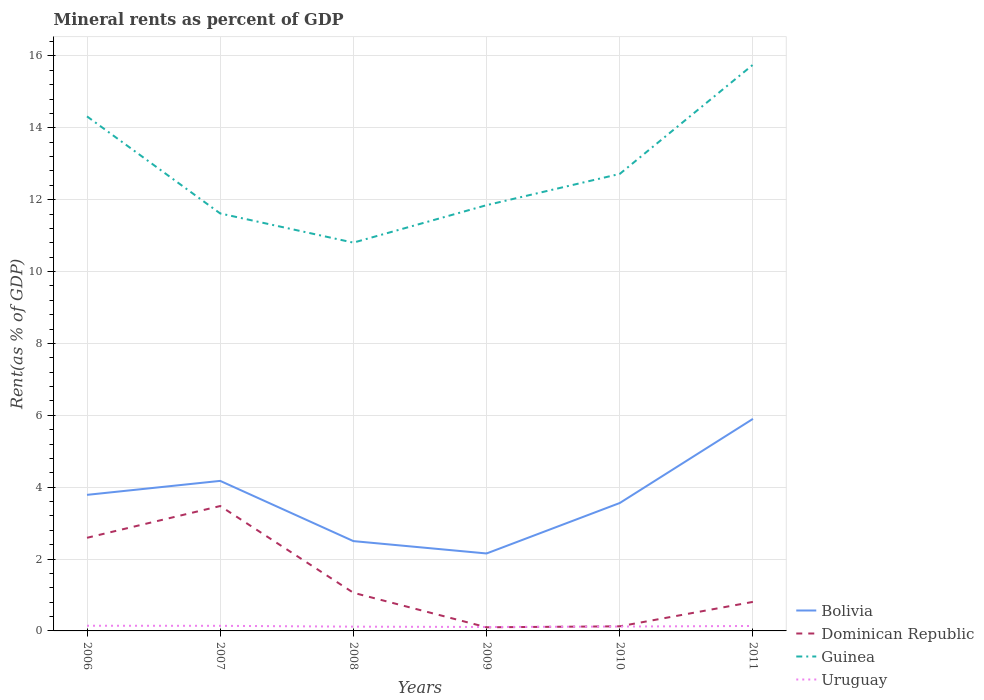Is the number of lines equal to the number of legend labels?
Offer a terse response. Yes. Across all years, what is the maximum mineral rent in Dominican Republic?
Provide a short and direct response. 0.1. What is the total mineral rent in Uruguay in the graph?
Offer a very short reply. -0.03. What is the difference between the highest and the second highest mineral rent in Uruguay?
Ensure brevity in your answer.  0.03. Is the mineral rent in Guinea strictly greater than the mineral rent in Dominican Republic over the years?
Make the answer very short. No. How many lines are there?
Make the answer very short. 4. Where does the legend appear in the graph?
Your response must be concise. Bottom right. How many legend labels are there?
Your answer should be very brief. 4. What is the title of the graph?
Your answer should be compact. Mineral rents as percent of GDP. Does "Rwanda" appear as one of the legend labels in the graph?
Your answer should be compact. No. What is the label or title of the Y-axis?
Ensure brevity in your answer.  Rent(as % of GDP). What is the Rent(as % of GDP) of Bolivia in 2006?
Make the answer very short. 3.79. What is the Rent(as % of GDP) in Dominican Republic in 2006?
Give a very brief answer. 2.59. What is the Rent(as % of GDP) in Guinea in 2006?
Your answer should be very brief. 14.32. What is the Rent(as % of GDP) in Uruguay in 2006?
Offer a terse response. 0.14. What is the Rent(as % of GDP) in Bolivia in 2007?
Your response must be concise. 4.17. What is the Rent(as % of GDP) in Dominican Republic in 2007?
Offer a terse response. 3.47. What is the Rent(as % of GDP) of Guinea in 2007?
Your answer should be very brief. 11.62. What is the Rent(as % of GDP) in Uruguay in 2007?
Your response must be concise. 0.14. What is the Rent(as % of GDP) of Bolivia in 2008?
Keep it short and to the point. 2.5. What is the Rent(as % of GDP) of Dominican Republic in 2008?
Your response must be concise. 1.06. What is the Rent(as % of GDP) of Guinea in 2008?
Keep it short and to the point. 10.8. What is the Rent(as % of GDP) in Uruguay in 2008?
Offer a very short reply. 0.12. What is the Rent(as % of GDP) in Bolivia in 2009?
Offer a terse response. 2.16. What is the Rent(as % of GDP) of Dominican Republic in 2009?
Offer a terse response. 0.1. What is the Rent(as % of GDP) of Guinea in 2009?
Give a very brief answer. 11.85. What is the Rent(as % of GDP) of Uruguay in 2009?
Give a very brief answer. 0.11. What is the Rent(as % of GDP) of Bolivia in 2010?
Keep it short and to the point. 3.56. What is the Rent(as % of GDP) in Dominican Republic in 2010?
Offer a terse response. 0.13. What is the Rent(as % of GDP) in Guinea in 2010?
Ensure brevity in your answer.  12.72. What is the Rent(as % of GDP) of Uruguay in 2010?
Ensure brevity in your answer.  0.12. What is the Rent(as % of GDP) in Bolivia in 2011?
Give a very brief answer. 5.9. What is the Rent(as % of GDP) of Dominican Republic in 2011?
Offer a terse response. 0.81. What is the Rent(as % of GDP) in Guinea in 2011?
Ensure brevity in your answer.  15.76. What is the Rent(as % of GDP) of Uruguay in 2011?
Give a very brief answer. 0.14. Across all years, what is the maximum Rent(as % of GDP) in Bolivia?
Give a very brief answer. 5.9. Across all years, what is the maximum Rent(as % of GDP) in Dominican Republic?
Make the answer very short. 3.47. Across all years, what is the maximum Rent(as % of GDP) in Guinea?
Keep it short and to the point. 15.76. Across all years, what is the maximum Rent(as % of GDP) of Uruguay?
Your response must be concise. 0.14. Across all years, what is the minimum Rent(as % of GDP) of Bolivia?
Provide a succinct answer. 2.16. Across all years, what is the minimum Rent(as % of GDP) in Dominican Republic?
Provide a short and direct response. 0.1. Across all years, what is the minimum Rent(as % of GDP) of Guinea?
Ensure brevity in your answer.  10.8. Across all years, what is the minimum Rent(as % of GDP) in Uruguay?
Offer a very short reply. 0.11. What is the total Rent(as % of GDP) in Bolivia in the graph?
Ensure brevity in your answer.  22.08. What is the total Rent(as % of GDP) of Dominican Republic in the graph?
Keep it short and to the point. 8.17. What is the total Rent(as % of GDP) in Guinea in the graph?
Provide a succinct answer. 77.06. What is the total Rent(as % of GDP) of Uruguay in the graph?
Offer a very short reply. 0.77. What is the difference between the Rent(as % of GDP) in Bolivia in 2006 and that in 2007?
Offer a terse response. -0.39. What is the difference between the Rent(as % of GDP) of Dominican Republic in 2006 and that in 2007?
Ensure brevity in your answer.  -0.88. What is the difference between the Rent(as % of GDP) of Guinea in 2006 and that in 2007?
Ensure brevity in your answer.  2.7. What is the difference between the Rent(as % of GDP) in Uruguay in 2006 and that in 2007?
Offer a very short reply. 0. What is the difference between the Rent(as % of GDP) of Bolivia in 2006 and that in 2008?
Provide a short and direct response. 1.29. What is the difference between the Rent(as % of GDP) in Dominican Republic in 2006 and that in 2008?
Provide a short and direct response. 1.53. What is the difference between the Rent(as % of GDP) of Guinea in 2006 and that in 2008?
Provide a short and direct response. 3.51. What is the difference between the Rent(as % of GDP) of Uruguay in 2006 and that in 2008?
Offer a very short reply. 0.03. What is the difference between the Rent(as % of GDP) in Bolivia in 2006 and that in 2009?
Offer a terse response. 1.63. What is the difference between the Rent(as % of GDP) of Dominican Republic in 2006 and that in 2009?
Your answer should be compact. 2.49. What is the difference between the Rent(as % of GDP) in Guinea in 2006 and that in 2009?
Your answer should be compact. 2.47. What is the difference between the Rent(as % of GDP) in Uruguay in 2006 and that in 2009?
Offer a terse response. 0.03. What is the difference between the Rent(as % of GDP) in Bolivia in 2006 and that in 2010?
Offer a very short reply. 0.23. What is the difference between the Rent(as % of GDP) of Dominican Republic in 2006 and that in 2010?
Offer a very short reply. 2.46. What is the difference between the Rent(as % of GDP) in Guinea in 2006 and that in 2010?
Offer a terse response. 1.6. What is the difference between the Rent(as % of GDP) in Uruguay in 2006 and that in 2010?
Make the answer very short. 0.02. What is the difference between the Rent(as % of GDP) of Bolivia in 2006 and that in 2011?
Your answer should be compact. -2.11. What is the difference between the Rent(as % of GDP) of Dominican Republic in 2006 and that in 2011?
Make the answer very short. 1.78. What is the difference between the Rent(as % of GDP) of Guinea in 2006 and that in 2011?
Keep it short and to the point. -1.44. What is the difference between the Rent(as % of GDP) in Uruguay in 2006 and that in 2011?
Your answer should be compact. 0.01. What is the difference between the Rent(as % of GDP) of Bolivia in 2007 and that in 2008?
Offer a terse response. 1.68. What is the difference between the Rent(as % of GDP) of Dominican Republic in 2007 and that in 2008?
Give a very brief answer. 2.41. What is the difference between the Rent(as % of GDP) of Guinea in 2007 and that in 2008?
Ensure brevity in your answer.  0.81. What is the difference between the Rent(as % of GDP) of Uruguay in 2007 and that in 2008?
Offer a terse response. 0.02. What is the difference between the Rent(as % of GDP) of Bolivia in 2007 and that in 2009?
Your response must be concise. 2.02. What is the difference between the Rent(as % of GDP) in Dominican Republic in 2007 and that in 2009?
Your answer should be very brief. 3.37. What is the difference between the Rent(as % of GDP) of Guinea in 2007 and that in 2009?
Your answer should be very brief. -0.23. What is the difference between the Rent(as % of GDP) of Uruguay in 2007 and that in 2009?
Your answer should be compact. 0.03. What is the difference between the Rent(as % of GDP) in Bolivia in 2007 and that in 2010?
Your answer should be very brief. 0.62. What is the difference between the Rent(as % of GDP) in Dominican Republic in 2007 and that in 2010?
Make the answer very short. 3.35. What is the difference between the Rent(as % of GDP) of Guinea in 2007 and that in 2010?
Your response must be concise. -1.1. What is the difference between the Rent(as % of GDP) of Uruguay in 2007 and that in 2010?
Provide a succinct answer. 0.02. What is the difference between the Rent(as % of GDP) in Bolivia in 2007 and that in 2011?
Offer a terse response. -1.73. What is the difference between the Rent(as % of GDP) of Dominican Republic in 2007 and that in 2011?
Make the answer very short. 2.67. What is the difference between the Rent(as % of GDP) of Guinea in 2007 and that in 2011?
Provide a short and direct response. -4.14. What is the difference between the Rent(as % of GDP) in Uruguay in 2007 and that in 2011?
Provide a succinct answer. 0. What is the difference between the Rent(as % of GDP) in Bolivia in 2008 and that in 2009?
Offer a very short reply. 0.34. What is the difference between the Rent(as % of GDP) in Dominican Republic in 2008 and that in 2009?
Your answer should be compact. 0.96. What is the difference between the Rent(as % of GDP) of Guinea in 2008 and that in 2009?
Provide a succinct answer. -1.04. What is the difference between the Rent(as % of GDP) of Uruguay in 2008 and that in 2009?
Ensure brevity in your answer.  0.01. What is the difference between the Rent(as % of GDP) in Bolivia in 2008 and that in 2010?
Your answer should be very brief. -1.06. What is the difference between the Rent(as % of GDP) in Dominican Republic in 2008 and that in 2010?
Offer a very short reply. 0.93. What is the difference between the Rent(as % of GDP) in Guinea in 2008 and that in 2010?
Offer a terse response. -1.91. What is the difference between the Rent(as % of GDP) in Uruguay in 2008 and that in 2010?
Your answer should be very brief. -0. What is the difference between the Rent(as % of GDP) in Bolivia in 2008 and that in 2011?
Give a very brief answer. -3.4. What is the difference between the Rent(as % of GDP) of Dominican Republic in 2008 and that in 2011?
Ensure brevity in your answer.  0.25. What is the difference between the Rent(as % of GDP) of Guinea in 2008 and that in 2011?
Provide a short and direct response. -4.95. What is the difference between the Rent(as % of GDP) of Uruguay in 2008 and that in 2011?
Make the answer very short. -0.02. What is the difference between the Rent(as % of GDP) in Bolivia in 2009 and that in 2010?
Make the answer very short. -1.4. What is the difference between the Rent(as % of GDP) of Dominican Republic in 2009 and that in 2010?
Offer a terse response. -0.03. What is the difference between the Rent(as % of GDP) of Guinea in 2009 and that in 2010?
Offer a very short reply. -0.87. What is the difference between the Rent(as % of GDP) in Uruguay in 2009 and that in 2010?
Provide a short and direct response. -0.01. What is the difference between the Rent(as % of GDP) in Bolivia in 2009 and that in 2011?
Your answer should be compact. -3.75. What is the difference between the Rent(as % of GDP) in Dominican Republic in 2009 and that in 2011?
Your answer should be compact. -0.71. What is the difference between the Rent(as % of GDP) of Guinea in 2009 and that in 2011?
Offer a terse response. -3.91. What is the difference between the Rent(as % of GDP) of Uruguay in 2009 and that in 2011?
Make the answer very short. -0.03. What is the difference between the Rent(as % of GDP) of Bolivia in 2010 and that in 2011?
Keep it short and to the point. -2.34. What is the difference between the Rent(as % of GDP) of Dominican Republic in 2010 and that in 2011?
Offer a very short reply. -0.68. What is the difference between the Rent(as % of GDP) in Guinea in 2010 and that in 2011?
Ensure brevity in your answer.  -3.04. What is the difference between the Rent(as % of GDP) of Uruguay in 2010 and that in 2011?
Give a very brief answer. -0.02. What is the difference between the Rent(as % of GDP) of Bolivia in 2006 and the Rent(as % of GDP) of Dominican Republic in 2007?
Your response must be concise. 0.31. What is the difference between the Rent(as % of GDP) in Bolivia in 2006 and the Rent(as % of GDP) in Guinea in 2007?
Offer a terse response. -7.83. What is the difference between the Rent(as % of GDP) of Bolivia in 2006 and the Rent(as % of GDP) of Uruguay in 2007?
Give a very brief answer. 3.64. What is the difference between the Rent(as % of GDP) of Dominican Republic in 2006 and the Rent(as % of GDP) of Guinea in 2007?
Keep it short and to the point. -9.02. What is the difference between the Rent(as % of GDP) of Dominican Republic in 2006 and the Rent(as % of GDP) of Uruguay in 2007?
Your answer should be compact. 2.45. What is the difference between the Rent(as % of GDP) in Guinea in 2006 and the Rent(as % of GDP) in Uruguay in 2007?
Make the answer very short. 14.18. What is the difference between the Rent(as % of GDP) in Bolivia in 2006 and the Rent(as % of GDP) in Dominican Republic in 2008?
Offer a very short reply. 2.72. What is the difference between the Rent(as % of GDP) in Bolivia in 2006 and the Rent(as % of GDP) in Guinea in 2008?
Keep it short and to the point. -7.02. What is the difference between the Rent(as % of GDP) in Bolivia in 2006 and the Rent(as % of GDP) in Uruguay in 2008?
Offer a terse response. 3.67. What is the difference between the Rent(as % of GDP) in Dominican Republic in 2006 and the Rent(as % of GDP) in Guinea in 2008?
Make the answer very short. -8.21. What is the difference between the Rent(as % of GDP) of Dominican Republic in 2006 and the Rent(as % of GDP) of Uruguay in 2008?
Provide a short and direct response. 2.47. What is the difference between the Rent(as % of GDP) of Guinea in 2006 and the Rent(as % of GDP) of Uruguay in 2008?
Ensure brevity in your answer.  14.2. What is the difference between the Rent(as % of GDP) in Bolivia in 2006 and the Rent(as % of GDP) in Dominican Republic in 2009?
Provide a succinct answer. 3.68. What is the difference between the Rent(as % of GDP) of Bolivia in 2006 and the Rent(as % of GDP) of Guinea in 2009?
Your response must be concise. -8.06. What is the difference between the Rent(as % of GDP) in Bolivia in 2006 and the Rent(as % of GDP) in Uruguay in 2009?
Offer a very short reply. 3.68. What is the difference between the Rent(as % of GDP) in Dominican Republic in 2006 and the Rent(as % of GDP) in Guinea in 2009?
Your answer should be compact. -9.26. What is the difference between the Rent(as % of GDP) of Dominican Republic in 2006 and the Rent(as % of GDP) of Uruguay in 2009?
Ensure brevity in your answer.  2.48. What is the difference between the Rent(as % of GDP) of Guinea in 2006 and the Rent(as % of GDP) of Uruguay in 2009?
Your answer should be compact. 14.21. What is the difference between the Rent(as % of GDP) of Bolivia in 2006 and the Rent(as % of GDP) of Dominican Republic in 2010?
Provide a short and direct response. 3.66. What is the difference between the Rent(as % of GDP) in Bolivia in 2006 and the Rent(as % of GDP) in Guinea in 2010?
Your response must be concise. -8.93. What is the difference between the Rent(as % of GDP) in Bolivia in 2006 and the Rent(as % of GDP) in Uruguay in 2010?
Provide a short and direct response. 3.66. What is the difference between the Rent(as % of GDP) of Dominican Republic in 2006 and the Rent(as % of GDP) of Guinea in 2010?
Your answer should be very brief. -10.13. What is the difference between the Rent(as % of GDP) of Dominican Republic in 2006 and the Rent(as % of GDP) of Uruguay in 2010?
Offer a terse response. 2.47. What is the difference between the Rent(as % of GDP) in Guinea in 2006 and the Rent(as % of GDP) in Uruguay in 2010?
Offer a terse response. 14.2. What is the difference between the Rent(as % of GDP) in Bolivia in 2006 and the Rent(as % of GDP) in Dominican Republic in 2011?
Provide a succinct answer. 2.98. What is the difference between the Rent(as % of GDP) of Bolivia in 2006 and the Rent(as % of GDP) of Guinea in 2011?
Your answer should be very brief. -11.97. What is the difference between the Rent(as % of GDP) in Bolivia in 2006 and the Rent(as % of GDP) in Uruguay in 2011?
Provide a succinct answer. 3.65. What is the difference between the Rent(as % of GDP) in Dominican Republic in 2006 and the Rent(as % of GDP) in Guinea in 2011?
Provide a short and direct response. -13.16. What is the difference between the Rent(as % of GDP) in Dominican Republic in 2006 and the Rent(as % of GDP) in Uruguay in 2011?
Provide a succinct answer. 2.45. What is the difference between the Rent(as % of GDP) of Guinea in 2006 and the Rent(as % of GDP) of Uruguay in 2011?
Your answer should be compact. 14.18. What is the difference between the Rent(as % of GDP) in Bolivia in 2007 and the Rent(as % of GDP) in Dominican Republic in 2008?
Your response must be concise. 3.11. What is the difference between the Rent(as % of GDP) of Bolivia in 2007 and the Rent(as % of GDP) of Guinea in 2008?
Your answer should be compact. -6.63. What is the difference between the Rent(as % of GDP) in Bolivia in 2007 and the Rent(as % of GDP) in Uruguay in 2008?
Your answer should be very brief. 4.06. What is the difference between the Rent(as % of GDP) in Dominican Republic in 2007 and the Rent(as % of GDP) in Guinea in 2008?
Provide a succinct answer. -7.33. What is the difference between the Rent(as % of GDP) of Dominican Republic in 2007 and the Rent(as % of GDP) of Uruguay in 2008?
Provide a succinct answer. 3.36. What is the difference between the Rent(as % of GDP) in Guinea in 2007 and the Rent(as % of GDP) in Uruguay in 2008?
Your response must be concise. 11.5. What is the difference between the Rent(as % of GDP) in Bolivia in 2007 and the Rent(as % of GDP) in Dominican Republic in 2009?
Your response must be concise. 4.07. What is the difference between the Rent(as % of GDP) of Bolivia in 2007 and the Rent(as % of GDP) of Guinea in 2009?
Your answer should be very brief. -7.67. What is the difference between the Rent(as % of GDP) in Bolivia in 2007 and the Rent(as % of GDP) in Uruguay in 2009?
Ensure brevity in your answer.  4.07. What is the difference between the Rent(as % of GDP) in Dominican Republic in 2007 and the Rent(as % of GDP) in Guinea in 2009?
Give a very brief answer. -8.37. What is the difference between the Rent(as % of GDP) in Dominican Republic in 2007 and the Rent(as % of GDP) in Uruguay in 2009?
Ensure brevity in your answer.  3.37. What is the difference between the Rent(as % of GDP) in Guinea in 2007 and the Rent(as % of GDP) in Uruguay in 2009?
Give a very brief answer. 11.51. What is the difference between the Rent(as % of GDP) of Bolivia in 2007 and the Rent(as % of GDP) of Dominican Republic in 2010?
Provide a short and direct response. 4.05. What is the difference between the Rent(as % of GDP) in Bolivia in 2007 and the Rent(as % of GDP) in Guinea in 2010?
Offer a terse response. -8.54. What is the difference between the Rent(as % of GDP) of Bolivia in 2007 and the Rent(as % of GDP) of Uruguay in 2010?
Your response must be concise. 4.05. What is the difference between the Rent(as % of GDP) of Dominican Republic in 2007 and the Rent(as % of GDP) of Guinea in 2010?
Offer a very short reply. -9.24. What is the difference between the Rent(as % of GDP) of Dominican Republic in 2007 and the Rent(as % of GDP) of Uruguay in 2010?
Your answer should be very brief. 3.35. What is the difference between the Rent(as % of GDP) of Guinea in 2007 and the Rent(as % of GDP) of Uruguay in 2010?
Give a very brief answer. 11.49. What is the difference between the Rent(as % of GDP) in Bolivia in 2007 and the Rent(as % of GDP) in Dominican Republic in 2011?
Keep it short and to the point. 3.37. What is the difference between the Rent(as % of GDP) in Bolivia in 2007 and the Rent(as % of GDP) in Guinea in 2011?
Offer a very short reply. -11.58. What is the difference between the Rent(as % of GDP) of Bolivia in 2007 and the Rent(as % of GDP) of Uruguay in 2011?
Offer a terse response. 4.04. What is the difference between the Rent(as % of GDP) in Dominican Republic in 2007 and the Rent(as % of GDP) in Guinea in 2011?
Provide a short and direct response. -12.28. What is the difference between the Rent(as % of GDP) of Dominican Republic in 2007 and the Rent(as % of GDP) of Uruguay in 2011?
Your answer should be compact. 3.34. What is the difference between the Rent(as % of GDP) of Guinea in 2007 and the Rent(as % of GDP) of Uruguay in 2011?
Offer a very short reply. 11.48. What is the difference between the Rent(as % of GDP) of Bolivia in 2008 and the Rent(as % of GDP) of Dominican Republic in 2009?
Provide a succinct answer. 2.4. What is the difference between the Rent(as % of GDP) in Bolivia in 2008 and the Rent(as % of GDP) in Guinea in 2009?
Make the answer very short. -9.35. What is the difference between the Rent(as % of GDP) in Bolivia in 2008 and the Rent(as % of GDP) in Uruguay in 2009?
Your response must be concise. 2.39. What is the difference between the Rent(as % of GDP) in Dominican Republic in 2008 and the Rent(as % of GDP) in Guinea in 2009?
Ensure brevity in your answer.  -10.79. What is the difference between the Rent(as % of GDP) of Dominican Republic in 2008 and the Rent(as % of GDP) of Uruguay in 2009?
Your response must be concise. 0.95. What is the difference between the Rent(as % of GDP) in Guinea in 2008 and the Rent(as % of GDP) in Uruguay in 2009?
Ensure brevity in your answer.  10.69. What is the difference between the Rent(as % of GDP) in Bolivia in 2008 and the Rent(as % of GDP) in Dominican Republic in 2010?
Your response must be concise. 2.37. What is the difference between the Rent(as % of GDP) of Bolivia in 2008 and the Rent(as % of GDP) of Guinea in 2010?
Provide a succinct answer. -10.22. What is the difference between the Rent(as % of GDP) of Bolivia in 2008 and the Rent(as % of GDP) of Uruguay in 2010?
Provide a short and direct response. 2.38. What is the difference between the Rent(as % of GDP) of Dominican Republic in 2008 and the Rent(as % of GDP) of Guinea in 2010?
Your answer should be very brief. -11.66. What is the difference between the Rent(as % of GDP) in Dominican Republic in 2008 and the Rent(as % of GDP) in Uruguay in 2010?
Ensure brevity in your answer.  0.94. What is the difference between the Rent(as % of GDP) of Guinea in 2008 and the Rent(as % of GDP) of Uruguay in 2010?
Provide a short and direct response. 10.68. What is the difference between the Rent(as % of GDP) in Bolivia in 2008 and the Rent(as % of GDP) in Dominican Republic in 2011?
Your answer should be very brief. 1.69. What is the difference between the Rent(as % of GDP) of Bolivia in 2008 and the Rent(as % of GDP) of Guinea in 2011?
Offer a very short reply. -13.26. What is the difference between the Rent(as % of GDP) in Bolivia in 2008 and the Rent(as % of GDP) in Uruguay in 2011?
Make the answer very short. 2.36. What is the difference between the Rent(as % of GDP) in Dominican Republic in 2008 and the Rent(as % of GDP) in Guinea in 2011?
Offer a terse response. -14.69. What is the difference between the Rent(as % of GDP) in Dominican Republic in 2008 and the Rent(as % of GDP) in Uruguay in 2011?
Your response must be concise. 0.92. What is the difference between the Rent(as % of GDP) in Guinea in 2008 and the Rent(as % of GDP) in Uruguay in 2011?
Offer a very short reply. 10.67. What is the difference between the Rent(as % of GDP) of Bolivia in 2009 and the Rent(as % of GDP) of Dominican Republic in 2010?
Your answer should be very brief. 2.03. What is the difference between the Rent(as % of GDP) of Bolivia in 2009 and the Rent(as % of GDP) of Guinea in 2010?
Your answer should be very brief. -10.56. What is the difference between the Rent(as % of GDP) of Bolivia in 2009 and the Rent(as % of GDP) of Uruguay in 2010?
Your answer should be very brief. 2.03. What is the difference between the Rent(as % of GDP) in Dominican Republic in 2009 and the Rent(as % of GDP) in Guinea in 2010?
Offer a very short reply. -12.62. What is the difference between the Rent(as % of GDP) in Dominican Republic in 2009 and the Rent(as % of GDP) in Uruguay in 2010?
Provide a short and direct response. -0.02. What is the difference between the Rent(as % of GDP) of Guinea in 2009 and the Rent(as % of GDP) of Uruguay in 2010?
Provide a short and direct response. 11.73. What is the difference between the Rent(as % of GDP) in Bolivia in 2009 and the Rent(as % of GDP) in Dominican Republic in 2011?
Your answer should be very brief. 1.35. What is the difference between the Rent(as % of GDP) in Bolivia in 2009 and the Rent(as % of GDP) in Guinea in 2011?
Keep it short and to the point. -13.6. What is the difference between the Rent(as % of GDP) of Bolivia in 2009 and the Rent(as % of GDP) of Uruguay in 2011?
Your answer should be compact. 2.02. What is the difference between the Rent(as % of GDP) in Dominican Republic in 2009 and the Rent(as % of GDP) in Guinea in 2011?
Ensure brevity in your answer.  -15.65. What is the difference between the Rent(as % of GDP) in Dominican Republic in 2009 and the Rent(as % of GDP) in Uruguay in 2011?
Give a very brief answer. -0.04. What is the difference between the Rent(as % of GDP) of Guinea in 2009 and the Rent(as % of GDP) of Uruguay in 2011?
Offer a very short reply. 11.71. What is the difference between the Rent(as % of GDP) of Bolivia in 2010 and the Rent(as % of GDP) of Dominican Republic in 2011?
Offer a very short reply. 2.75. What is the difference between the Rent(as % of GDP) of Bolivia in 2010 and the Rent(as % of GDP) of Guinea in 2011?
Make the answer very short. -12.2. What is the difference between the Rent(as % of GDP) of Bolivia in 2010 and the Rent(as % of GDP) of Uruguay in 2011?
Your answer should be very brief. 3.42. What is the difference between the Rent(as % of GDP) in Dominican Republic in 2010 and the Rent(as % of GDP) in Guinea in 2011?
Give a very brief answer. -15.63. What is the difference between the Rent(as % of GDP) in Dominican Republic in 2010 and the Rent(as % of GDP) in Uruguay in 2011?
Offer a very short reply. -0.01. What is the difference between the Rent(as % of GDP) in Guinea in 2010 and the Rent(as % of GDP) in Uruguay in 2011?
Your answer should be very brief. 12.58. What is the average Rent(as % of GDP) in Bolivia per year?
Offer a very short reply. 3.68. What is the average Rent(as % of GDP) of Dominican Republic per year?
Offer a terse response. 1.36. What is the average Rent(as % of GDP) in Guinea per year?
Offer a very short reply. 12.84. What is the average Rent(as % of GDP) in Uruguay per year?
Offer a terse response. 0.13. In the year 2006, what is the difference between the Rent(as % of GDP) in Bolivia and Rent(as % of GDP) in Dominican Republic?
Your answer should be compact. 1.19. In the year 2006, what is the difference between the Rent(as % of GDP) in Bolivia and Rent(as % of GDP) in Guinea?
Provide a succinct answer. -10.53. In the year 2006, what is the difference between the Rent(as % of GDP) of Bolivia and Rent(as % of GDP) of Uruguay?
Your response must be concise. 3.64. In the year 2006, what is the difference between the Rent(as % of GDP) in Dominican Republic and Rent(as % of GDP) in Guinea?
Keep it short and to the point. -11.73. In the year 2006, what is the difference between the Rent(as % of GDP) of Dominican Republic and Rent(as % of GDP) of Uruguay?
Provide a short and direct response. 2.45. In the year 2006, what is the difference between the Rent(as % of GDP) of Guinea and Rent(as % of GDP) of Uruguay?
Provide a short and direct response. 14.17. In the year 2007, what is the difference between the Rent(as % of GDP) in Bolivia and Rent(as % of GDP) in Dominican Republic?
Give a very brief answer. 0.7. In the year 2007, what is the difference between the Rent(as % of GDP) of Bolivia and Rent(as % of GDP) of Guinea?
Your response must be concise. -7.44. In the year 2007, what is the difference between the Rent(as % of GDP) of Bolivia and Rent(as % of GDP) of Uruguay?
Make the answer very short. 4.03. In the year 2007, what is the difference between the Rent(as % of GDP) in Dominican Republic and Rent(as % of GDP) in Guinea?
Offer a very short reply. -8.14. In the year 2007, what is the difference between the Rent(as % of GDP) of Dominican Republic and Rent(as % of GDP) of Uruguay?
Provide a short and direct response. 3.33. In the year 2007, what is the difference between the Rent(as % of GDP) of Guinea and Rent(as % of GDP) of Uruguay?
Your response must be concise. 11.47. In the year 2008, what is the difference between the Rent(as % of GDP) of Bolivia and Rent(as % of GDP) of Dominican Republic?
Give a very brief answer. 1.44. In the year 2008, what is the difference between the Rent(as % of GDP) in Bolivia and Rent(as % of GDP) in Guinea?
Ensure brevity in your answer.  -8.31. In the year 2008, what is the difference between the Rent(as % of GDP) in Bolivia and Rent(as % of GDP) in Uruguay?
Make the answer very short. 2.38. In the year 2008, what is the difference between the Rent(as % of GDP) of Dominican Republic and Rent(as % of GDP) of Guinea?
Ensure brevity in your answer.  -9.74. In the year 2008, what is the difference between the Rent(as % of GDP) in Dominican Republic and Rent(as % of GDP) in Uruguay?
Your answer should be very brief. 0.94. In the year 2008, what is the difference between the Rent(as % of GDP) of Guinea and Rent(as % of GDP) of Uruguay?
Your answer should be compact. 10.69. In the year 2009, what is the difference between the Rent(as % of GDP) of Bolivia and Rent(as % of GDP) of Dominican Republic?
Your response must be concise. 2.05. In the year 2009, what is the difference between the Rent(as % of GDP) of Bolivia and Rent(as % of GDP) of Guinea?
Provide a short and direct response. -9.69. In the year 2009, what is the difference between the Rent(as % of GDP) in Bolivia and Rent(as % of GDP) in Uruguay?
Provide a succinct answer. 2.05. In the year 2009, what is the difference between the Rent(as % of GDP) in Dominican Republic and Rent(as % of GDP) in Guinea?
Make the answer very short. -11.75. In the year 2009, what is the difference between the Rent(as % of GDP) of Dominican Republic and Rent(as % of GDP) of Uruguay?
Your response must be concise. -0.01. In the year 2009, what is the difference between the Rent(as % of GDP) of Guinea and Rent(as % of GDP) of Uruguay?
Make the answer very short. 11.74. In the year 2010, what is the difference between the Rent(as % of GDP) in Bolivia and Rent(as % of GDP) in Dominican Republic?
Provide a succinct answer. 3.43. In the year 2010, what is the difference between the Rent(as % of GDP) of Bolivia and Rent(as % of GDP) of Guinea?
Provide a succinct answer. -9.16. In the year 2010, what is the difference between the Rent(as % of GDP) of Bolivia and Rent(as % of GDP) of Uruguay?
Provide a succinct answer. 3.44. In the year 2010, what is the difference between the Rent(as % of GDP) of Dominican Republic and Rent(as % of GDP) of Guinea?
Offer a very short reply. -12.59. In the year 2010, what is the difference between the Rent(as % of GDP) of Dominican Republic and Rent(as % of GDP) of Uruguay?
Your answer should be compact. 0.01. In the year 2010, what is the difference between the Rent(as % of GDP) of Guinea and Rent(as % of GDP) of Uruguay?
Your answer should be very brief. 12.6. In the year 2011, what is the difference between the Rent(as % of GDP) in Bolivia and Rent(as % of GDP) in Dominican Republic?
Your response must be concise. 5.09. In the year 2011, what is the difference between the Rent(as % of GDP) of Bolivia and Rent(as % of GDP) of Guinea?
Offer a terse response. -9.85. In the year 2011, what is the difference between the Rent(as % of GDP) of Bolivia and Rent(as % of GDP) of Uruguay?
Your answer should be compact. 5.76. In the year 2011, what is the difference between the Rent(as % of GDP) in Dominican Republic and Rent(as % of GDP) in Guinea?
Your answer should be compact. -14.95. In the year 2011, what is the difference between the Rent(as % of GDP) in Dominican Republic and Rent(as % of GDP) in Uruguay?
Offer a very short reply. 0.67. In the year 2011, what is the difference between the Rent(as % of GDP) in Guinea and Rent(as % of GDP) in Uruguay?
Ensure brevity in your answer.  15.62. What is the ratio of the Rent(as % of GDP) in Bolivia in 2006 to that in 2007?
Your answer should be compact. 0.91. What is the ratio of the Rent(as % of GDP) in Dominican Republic in 2006 to that in 2007?
Give a very brief answer. 0.75. What is the ratio of the Rent(as % of GDP) in Guinea in 2006 to that in 2007?
Offer a very short reply. 1.23. What is the ratio of the Rent(as % of GDP) of Uruguay in 2006 to that in 2007?
Offer a terse response. 1.02. What is the ratio of the Rent(as % of GDP) of Bolivia in 2006 to that in 2008?
Your answer should be very brief. 1.51. What is the ratio of the Rent(as % of GDP) in Dominican Republic in 2006 to that in 2008?
Ensure brevity in your answer.  2.44. What is the ratio of the Rent(as % of GDP) of Guinea in 2006 to that in 2008?
Your response must be concise. 1.33. What is the ratio of the Rent(as % of GDP) of Uruguay in 2006 to that in 2008?
Offer a very short reply. 1.21. What is the ratio of the Rent(as % of GDP) of Bolivia in 2006 to that in 2009?
Offer a terse response. 1.76. What is the ratio of the Rent(as % of GDP) in Dominican Republic in 2006 to that in 2009?
Offer a terse response. 25.57. What is the ratio of the Rent(as % of GDP) of Guinea in 2006 to that in 2009?
Ensure brevity in your answer.  1.21. What is the ratio of the Rent(as % of GDP) in Uruguay in 2006 to that in 2009?
Make the answer very short. 1.32. What is the ratio of the Rent(as % of GDP) of Bolivia in 2006 to that in 2010?
Provide a short and direct response. 1.06. What is the ratio of the Rent(as % of GDP) in Dominican Republic in 2006 to that in 2010?
Ensure brevity in your answer.  20.23. What is the ratio of the Rent(as % of GDP) in Guinea in 2006 to that in 2010?
Provide a succinct answer. 1.13. What is the ratio of the Rent(as % of GDP) of Uruguay in 2006 to that in 2010?
Make the answer very short. 1.19. What is the ratio of the Rent(as % of GDP) of Bolivia in 2006 to that in 2011?
Keep it short and to the point. 0.64. What is the ratio of the Rent(as % of GDP) of Dominican Republic in 2006 to that in 2011?
Your answer should be compact. 3.21. What is the ratio of the Rent(as % of GDP) of Guinea in 2006 to that in 2011?
Provide a succinct answer. 0.91. What is the ratio of the Rent(as % of GDP) of Uruguay in 2006 to that in 2011?
Ensure brevity in your answer.  1.05. What is the ratio of the Rent(as % of GDP) of Bolivia in 2007 to that in 2008?
Ensure brevity in your answer.  1.67. What is the ratio of the Rent(as % of GDP) in Dominican Republic in 2007 to that in 2008?
Your answer should be compact. 3.27. What is the ratio of the Rent(as % of GDP) in Guinea in 2007 to that in 2008?
Your response must be concise. 1.08. What is the ratio of the Rent(as % of GDP) in Uruguay in 2007 to that in 2008?
Give a very brief answer. 1.19. What is the ratio of the Rent(as % of GDP) in Bolivia in 2007 to that in 2009?
Ensure brevity in your answer.  1.94. What is the ratio of the Rent(as % of GDP) of Dominican Republic in 2007 to that in 2009?
Make the answer very short. 34.29. What is the ratio of the Rent(as % of GDP) of Guinea in 2007 to that in 2009?
Your answer should be compact. 0.98. What is the ratio of the Rent(as % of GDP) of Uruguay in 2007 to that in 2009?
Provide a succinct answer. 1.29. What is the ratio of the Rent(as % of GDP) in Bolivia in 2007 to that in 2010?
Offer a terse response. 1.17. What is the ratio of the Rent(as % of GDP) of Dominican Republic in 2007 to that in 2010?
Provide a succinct answer. 27.12. What is the ratio of the Rent(as % of GDP) in Guinea in 2007 to that in 2010?
Keep it short and to the point. 0.91. What is the ratio of the Rent(as % of GDP) in Uruguay in 2007 to that in 2010?
Offer a very short reply. 1.17. What is the ratio of the Rent(as % of GDP) of Bolivia in 2007 to that in 2011?
Offer a very short reply. 0.71. What is the ratio of the Rent(as % of GDP) of Dominican Republic in 2007 to that in 2011?
Give a very brief answer. 4.3. What is the ratio of the Rent(as % of GDP) of Guinea in 2007 to that in 2011?
Your answer should be very brief. 0.74. What is the ratio of the Rent(as % of GDP) in Uruguay in 2007 to that in 2011?
Offer a very short reply. 1.03. What is the ratio of the Rent(as % of GDP) of Bolivia in 2008 to that in 2009?
Offer a terse response. 1.16. What is the ratio of the Rent(as % of GDP) of Dominican Republic in 2008 to that in 2009?
Ensure brevity in your answer.  10.48. What is the ratio of the Rent(as % of GDP) in Guinea in 2008 to that in 2009?
Give a very brief answer. 0.91. What is the ratio of the Rent(as % of GDP) of Uruguay in 2008 to that in 2009?
Provide a succinct answer. 1.09. What is the ratio of the Rent(as % of GDP) of Bolivia in 2008 to that in 2010?
Give a very brief answer. 0.7. What is the ratio of the Rent(as % of GDP) in Dominican Republic in 2008 to that in 2010?
Offer a very short reply. 8.29. What is the ratio of the Rent(as % of GDP) of Guinea in 2008 to that in 2010?
Offer a terse response. 0.85. What is the ratio of the Rent(as % of GDP) in Uruguay in 2008 to that in 2010?
Your answer should be compact. 0.98. What is the ratio of the Rent(as % of GDP) of Bolivia in 2008 to that in 2011?
Give a very brief answer. 0.42. What is the ratio of the Rent(as % of GDP) of Dominican Republic in 2008 to that in 2011?
Provide a succinct answer. 1.31. What is the ratio of the Rent(as % of GDP) in Guinea in 2008 to that in 2011?
Your response must be concise. 0.69. What is the ratio of the Rent(as % of GDP) in Uruguay in 2008 to that in 2011?
Keep it short and to the point. 0.86. What is the ratio of the Rent(as % of GDP) in Bolivia in 2009 to that in 2010?
Your response must be concise. 0.61. What is the ratio of the Rent(as % of GDP) of Dominican Republic in 2009 to that in 2010?
Give a very brief answer. 0.79. What is the ratio of the Rent(as % of GDP) of Guinea in 2009 to that in 2010?
Provide a succinct answer. 0.93. What is the ratio of the Rent(as % of GDP) of Uruguay in 2009 to that in 2010?
Your answer should be compact. 0.9. What is the ratio of the Rent(as % of GDP) of Bolivia in 2009 to that in 2011?
Your response must be concise. 0.37. What is the ratio of the Rent(as % of GDP) of Dominican Republic in 2009 to that in 2011?
Your answer should be compact. 0.13. What is the ratio of the Rent(as % of GDP) in Guinea in 2009 to that in 2011?
Ensure brevity in your answer.  0.75. What is the ratio of the Rent(as % of GDP) of Uruguay in 2009 to that in 2011?
Keep it short and to the point. 0.8. What is the ratio of the Rent(as % of GDP) in Bolivia in 2010 to that in 2011?
Make the answer very short. 0.6. What is the ratio of the Rent(as % of GDP) of Dominican Republic in 2010 to that in 2011?
Provide a succinct answer. 0.16. What is the ratio of the Rent(as % of GDP) in Guinea in 2010 to that in 2011?
Your response must be concise. 0.81. What is the ratio of the Rent(as % of GDP) of Uruguay in 2010 to that in 2011?
Offer a terse response. 0.88. What is the difference between the highest and the second highest Rent(as % of GDP) of Bolivia?
Make the answer very short. 1.73. What is the difference between the highest and the second highest Rent(as % of GDP) of Dominican Republic?
Provide a short and direct response. 0.88. What is the difference between the highest and the second highest Rent(as % of GDP) of Guinea?
Provide a succinct answer. 1.44. What is the difference between the highest and the second highest Rent(as % of GDP) of Uruguay?
Offer a terse response. 0. What is the difference between the highest and the lowest Rent(as % of GDP) of Bolivia?
Provide a short and direct response. 3.75. What is the difference between the highest and the lowest Rent(as % of GDP) of Dominican Republic?
Provide a succinct answer. 3.37. What is the difference between the highest and the lowest Rent(as % of GDP) of Guinea?
Provide a succinct answer. 4.95. What is the difference between the highest and the lowest Rent(as % of GDP) of Uruguay?
Ensure brevity in your answer.  0.03. 